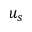<formula> <loc_0><loc_0><loc_500><loc_500>u _ { s }</formula> 